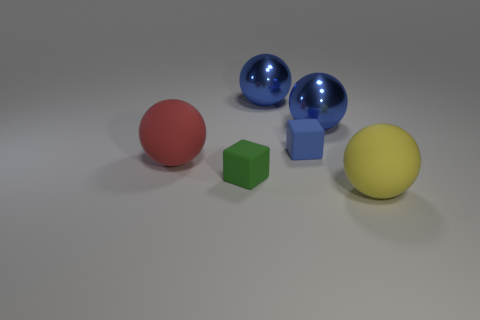Subtract all red rubber balls. How many balls are left? 3 Subtract all cyan cylinders. How many blue balls are left? 2 Subtract all red balls. How many balls are left? 3 Subtract 2 balls. How many balls are left? 2 Subtract all brown spheres. Subtract all cyan cubes. How many spheres are left? 4 Add 4 small rubber objects. How many objects exist? 10 Subtract all cubes. How many objects are left? 4 Subtract 1 blue blocks. How many objects are left? 5 Subtract all large yellow spheres. Subtract all small green cubes. How many objects are left? 4 Add 2 small green things. How many small green things are left? 3 